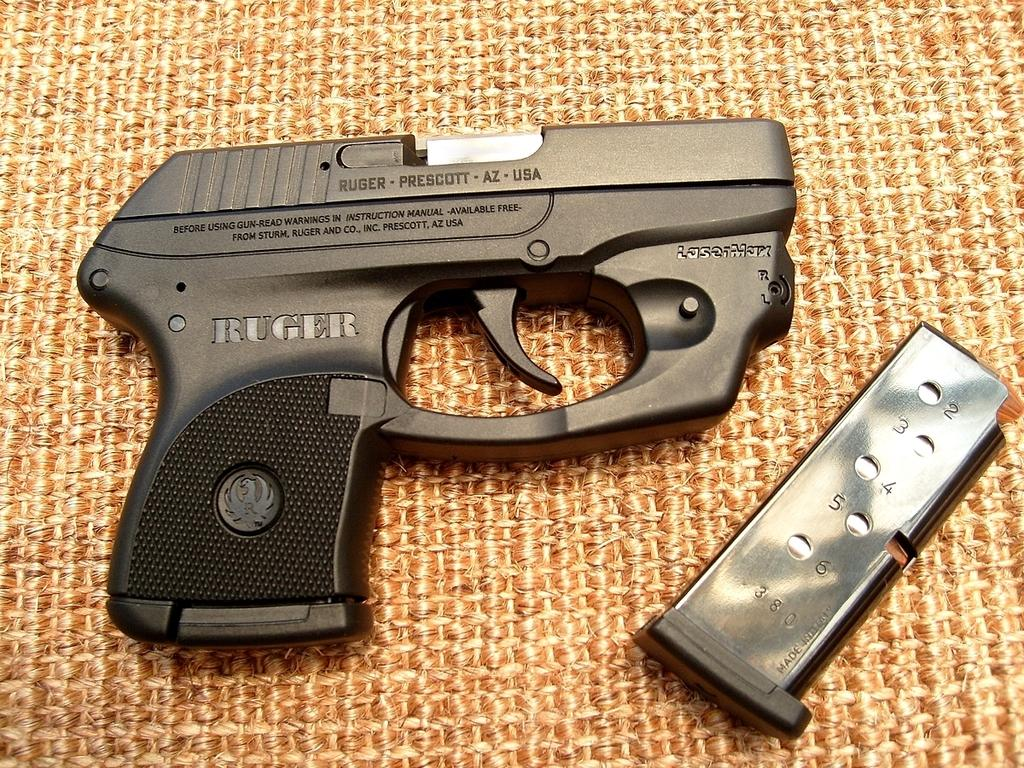What type of weapon is present in the image? There is a pistol in the image. What part of the pistol can be seen in the image? There is a detachable box magazine in the image. Where are the pistol and the detachable box magazine located? Both the pistol and the detachable box magazine are on a platform. What type of building can be seen in the background of the image? There is no building present in the image; it only features a pistol and a detachable box magazine on a platform. 